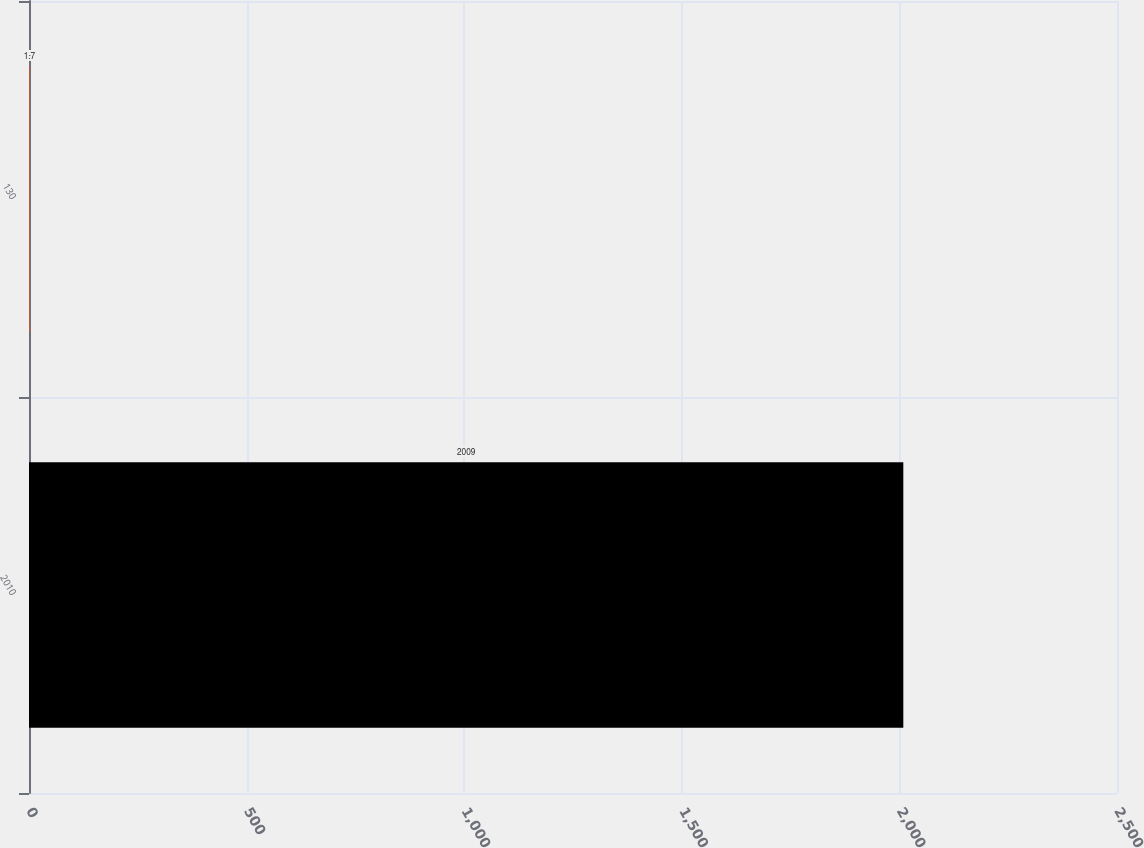Convert chart. <chart><loc_0><loc_0><loc_500><loc_500><bar_chart><fcel>2010<fcel>130<nl><fcel>2009<fcel>1.7<nl></chart> 